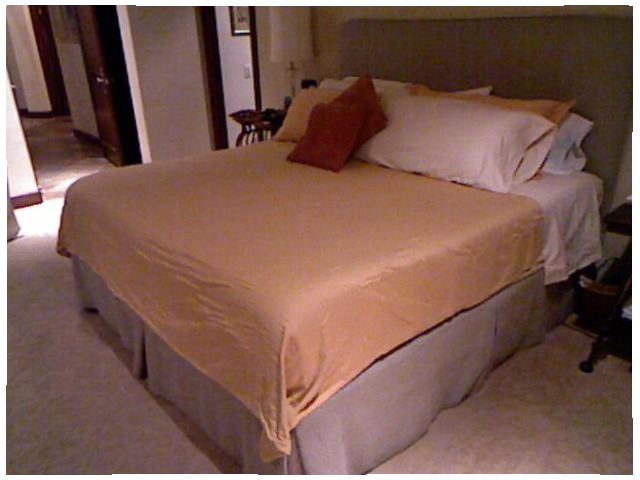<image>
Can you confirm if the pillow is under the bed? No. The pillow is not positioned under the bed. The vertical relationship between these objects is different. Is the pillow in front of the pillow? Yes. The pillow is positioned in front of the pillow, appearing closer to the camera viewpoint. Is the sofa in front of the sofa? No. The sofa is not in front of the sofa. The spatial positioning shows a different relationship between these objects. Where is the pillow in relation to the pillow? Is it on the pillow? Yes. Looking at the image, I can see the pillow is positioned on top of the pillow, with the pillow providing support. Is there a pillow on the bed? Yes. Looking at the image, I can see the pillow is positioned on top of the bed, with the bed providing support. 